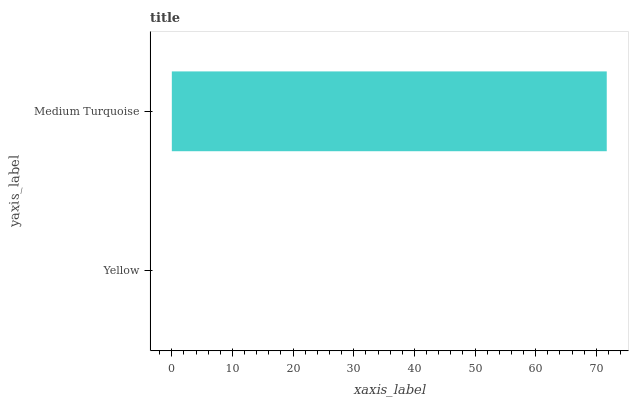Is Yellow the minimum?
Answer yes or no. Yes. Is Medium Turquoise the maximum?
Answer yes or no. Yes. Is Medium Turquoise the minimum?
Answer yes or no. No. Is Medium Turquoise greater than Yellow?
Answer yes or no. Yes. Is Yellow less than Medium Turquoise?
Answer yes or no. Yes. Is Yellow greater than Medium Turquoise?
Answer yes or no. No. Is Medium Turquoise less than Yellow?
Answer yes or no. No. Is Medium Turquoise the high median?
Answer yes or no. Yes. Is Yellow the low median?
Answer yes or no. Yes. Is Yellow the high median?
Answer yes or no. No. Is Medium Turquoise the low median?
Answer yes or no. No. 